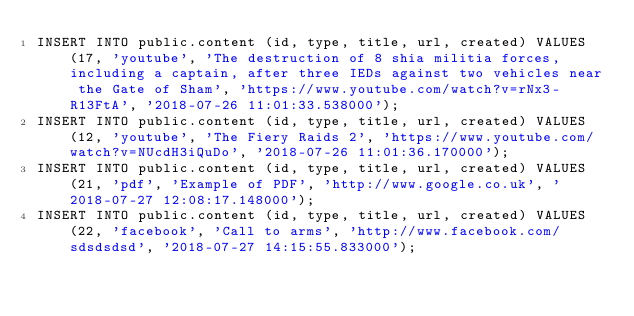<code> <loc_0><loc_0><loc_500><loc_500><_SQL_>INSERT INTO public.content (id, type, title, url, created) VALUES (17, 'youtube', 'The destruction of 8 shia militia forces, including a captain, after three IEDs against two vehicles near the Gate of Sham', 'https://www.youtube.com/watch?v=rNx3-R13FtA', '2018-07-26 11:01:33.538000');
INSERT INTO public.content (id, type, title, url, created) VALUES (12, 'youtube', 'The Fiery Raids 2', 'https://www.youtube.com/watch?v=NUcdH3iQuDo', '2018-07-26 11:01:36.170000');
INSERT INTO public.content (id, type, title, url, created) VALUES (21, 'pdf', 'Example of PDF', 'http://www.google.co.uk', '2018-07-27 12:08:17.148000');
INSERT INTO public.content (id, type, title, url, created) VALUES (22, 'facebook', 'Call to arms', 'http://www.facebook.com/sdsdsdsd', '2018-07-27 14:15:55.833000');</code> 